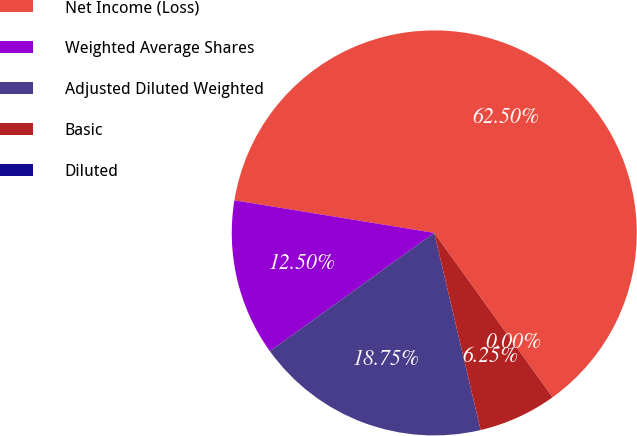Convert chart. <chart><loc_0><loc_0><loc_500><loc_500><pie_chart><fcel>Net Income (Loss)<fcel>Weighted Average Shares<fcel>Adjusted Diluted Weighted<fcel>Basic<fcel>Diluted<nl><fcel>62.5%<fcel>12.5%<fcel>18.75%<fcel>6.25%<fcel>0.0%<nl></chart> 